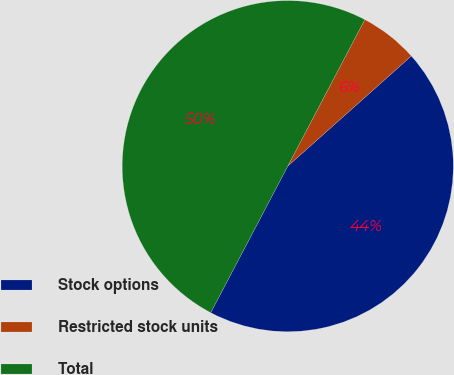Convert chart. <chart><loc_0><loc_0><loc_500><loc_500><pie_chart><fcel>Stock options<fcel>Restricted stock units<fcel>Total<nl><fcel>44.29%<fcel>5.71%<fcel>50.0%<nl></chart> 